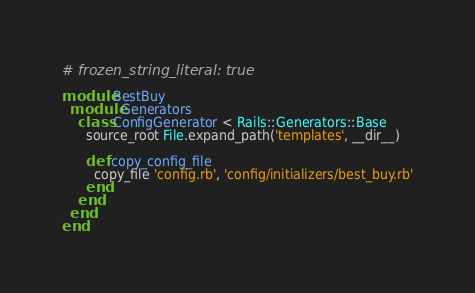<code> <loc_0><loc_0><loc_500><loc_500><_Ruby_># frozen_string_literal: true

module BestBuy
  module Generators
    class ConfigGenerator < Rails::Generators::Base
      source_root File.expand_path('templates', __dir__)

      def copy_config_file
        copy_file 'config.rb', 'config/initializers/best_buy.rb'
      end
    end
  end
end
</code> 